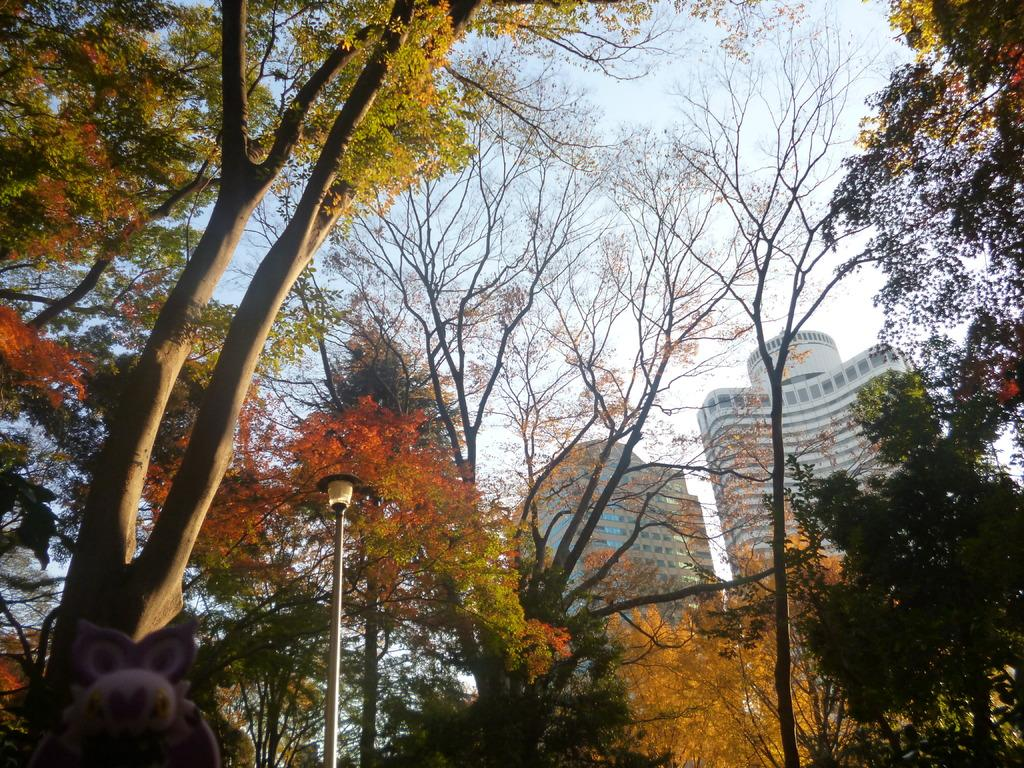What type of natural elements can be seen in the image? There are trees in the image. What man-made object is present in the image? There is a light pole in the image. Can you describe the object on the left side of the image? Unfortunately, the facts provided do not specify the nature of the object on the left side of the image. What can be seen in the distance in the image? There are buildings in the background of the image, and the sky is visible in the background as well. Who is the owner of the waste in the image? There is no waste present in the image, so it is not possible to determine an owner. What advice would you give to the dad in the image? There is no dad present in the image, so it is not possible to provide advice. 